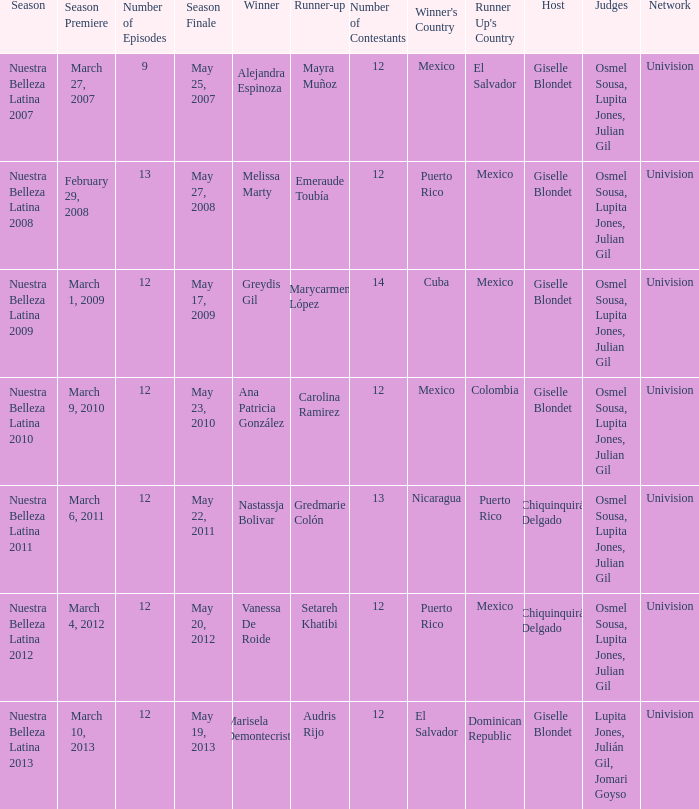How many contestants were there in a season where alejandra espinoza won? 1.0. 